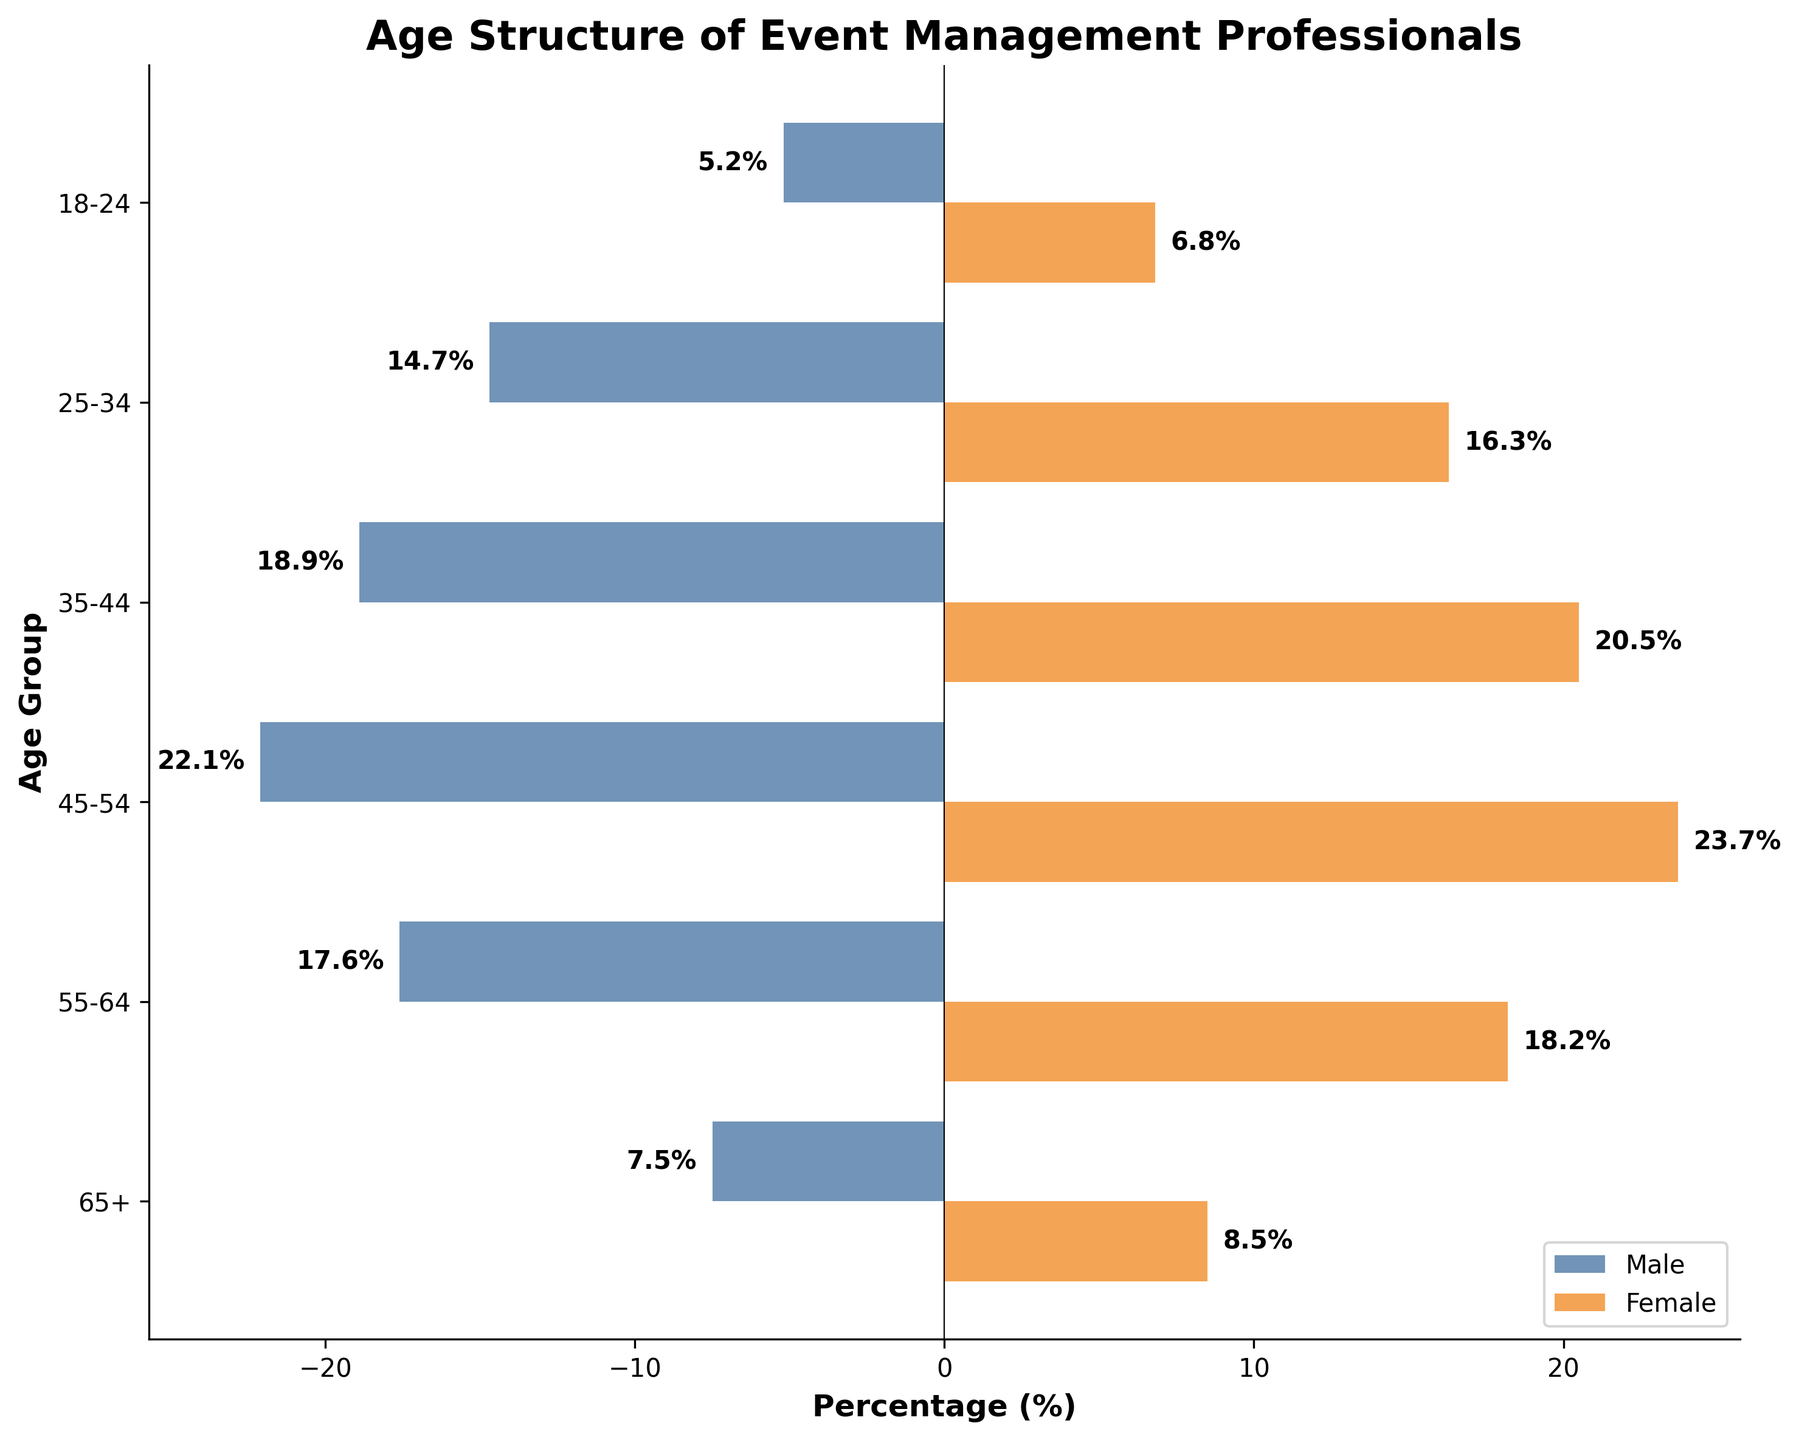What is the age group with the highest percentage of female event management professionals? Looking at the bars corresponding to each age group for females, the age group with the longest bar is 45-54, which has a percentage of 23.7%.
Answer: 45-54 Which age group shows a larger discrepancy between male and female percentages? Calculate the absolute difference between male and female percentages for each age group. The age group 45-54 shows the largest discrepancy:
Answer: 1.6% What is the sum of the percentages of male event management professionals in the age groups 18-24 and 25-34? Add the percentages of males in the 18-24 group (5.2) and the 25-34 group (14.7). 5.2% + 14.7% = 19.9%
Answer: 19.9% Which age group has the smallest percentage of male event management professionals? Looking at the bars corresponding to each age group for males, the 18-24 age group has the shortest bar with a percentage of 5.2%.
Answer: 18-24 By how much does the percentage of female event management professionals in the 65+ age group exceed that of males? Subtract the percentage of males in the 65+ age group (7.5) from the percentage of females (8.5). 8.5% - 7.5% = 1%
Answer: 1% Which age group has more than 20% of both male and female event management professionals? Check each age group's percentage for both genders, and the age group that exceeds 20% for both is 45-54.
Answer: 45-54 What is the range of percentages for male event management professionals? Find the difference between the highest and lowest male percentages. The highest is 22.1% (45-54) and the lowest is 5.2% (18-24). 22.1% - 5.2% = 16.9%
Answer: 16.9% What percentage of female event management professionals is in the 35-44 age group? Refer to the bar representing females in the 35-44 age group, it shows a value of 20.5%.
Answer: 20.5% What is the combined percentage of male event management professionals in the age groups 55-64 and 65+? Add the percentages of males in the 55-64 group (17.6) and the 65+ group (7.5). 17.6% + 7.5% = 25.1%
Answer: 25.1% Which gender has a higher population in the age group 25-34? Compare the lengths of the bars for males and females in the 25-34 age group. The female bar is longer with a value of 16.3% compared to the males' 14.7%.
Answer: Female 